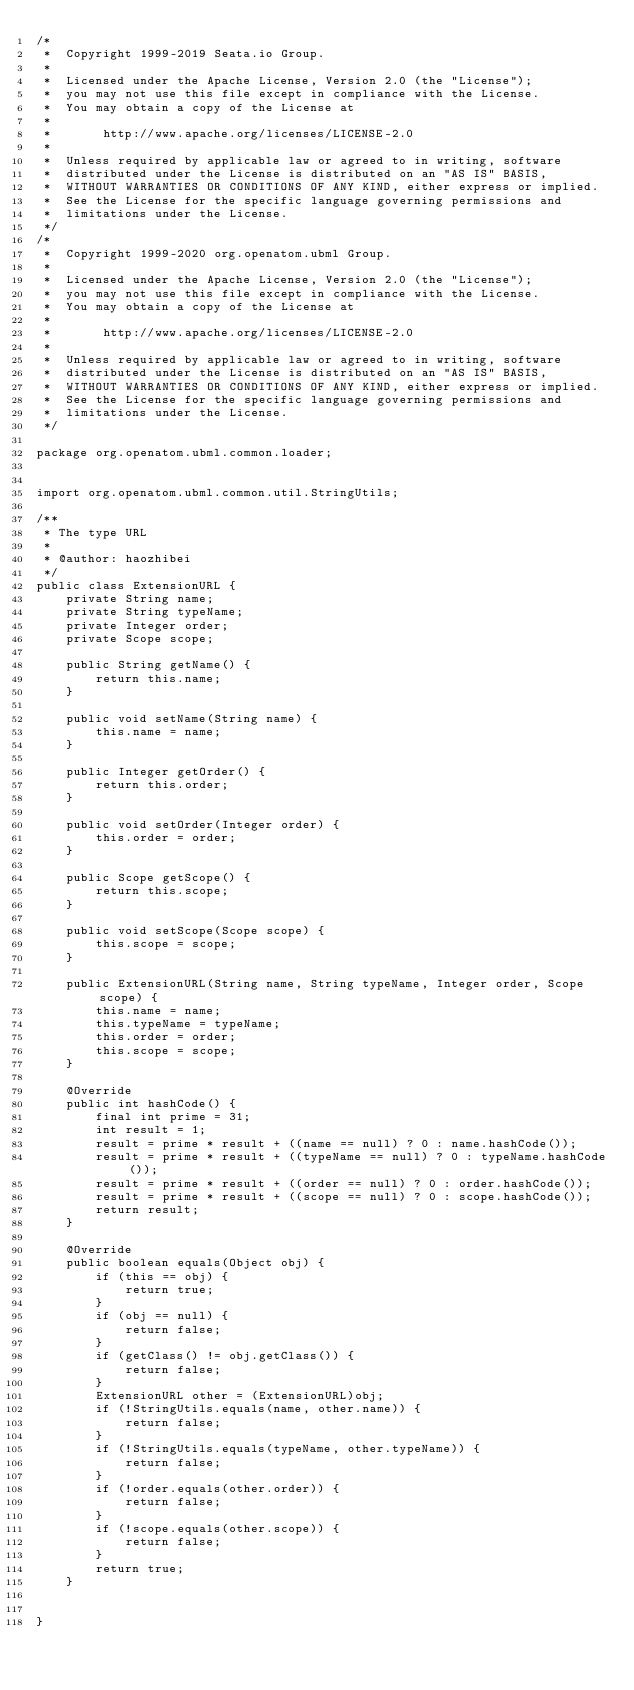<code> <loc_0><loc_0><loc_500><loc_500><_Java_>/*
 *  Copyright 1999-2019 Seata.io Group.
 *
 *  Licensed under the Apache License, Version 2.0 (the "License");
 *  you may not use this file except in compliance with the License.
 *  You may obtain a copy of the License at
 *
 *       http://www.apache.org/licenses/LICENSE-2.0
 *
 *  Unless required by applicable law or agreed to in writing, software
 *  distributed under the License is distributed on an "AS IS" BASIS,
 *  WITHOUT WARRANTIES OR CONDITIONS OF ANY KIND, either express or implied.
 *  See the License for the specific language governing permissions and
 *  limitations under the License.
 */
/*
 *  Copyright 1999-2020 org.openatom.ubml Group.
 *
 *  Licensed under the Apache License, Version 2.0 (the "License");
 *  you may not use this file except in compliance with the License.
 *  You may obtain a copy of the License at
 *
 *       http://www.apache.org/licenses/LICENSE-2.0
 *
 *  Unless required by applicable law or agreed to in writing, software
 *  distributed under the License is distributed on an "AS IS" BASIS,
 *  WITHOUT WARRANTIES OR CONDITIONS OF ANY KIND, either express or implied.
 *  See the License for the specific language governing permissions and
 *  limitations under the License.
 */

package org.openatom.ubml.common.loader;


import org.openatom.ubml.common.util.StringUtils;

/**
 * The type URL
 *
 * @author: haozhibei
 */
public class ExtensionURL {
    private String name;
    private String typeName;
    private Integer order;
    private Scope scope;

    public String getName() {
        return this.name;
    }

    public void setName(String name) {
        this.name = name;
    }

    public Integer getOrder() {
        return this.order;
    }

    public void setOrder(Integer order) {
        this.order = order;
    }

    public Scope getScope() {
        return this.scope;
    }

    public void setScope(Scope scope) {
        this.scope = scope;
    }

    public ExtensionURL(String name, String typeName, Integer order, Scope scope) {
        this.name = name;
        this.typeName = typeName;
        this.order = order;
        this.scope = scope;
    }

    @Override
    public int hashCode() {
        final int prime = 31;
        int result = 1;
        result = prime * result + ((name == null) ? 0 : name.hashCode());
        result = prime * result + ((typeName == null) ? 0 : typeName.hashCode());
        result = prime * result + ((order == null) ? 0 : order.hashCode());
        result = prime * result + ((scope == null) ? 0 : scope.hashCode());
        return result;
    }

    @Override
    public boolean equals(Object obj) {
        if (this == obj) {
            return true;
        }
        if (obj == null) {
            return false;
        }
        if (getClass() != obj.getClass()) {
            return false;
        }
        ExtensionURL other = (ExtensionURL)obj;
        if (!StringUtils.equals(name, other.name)) {
            return false;
        }
        if (!StringUtils.equals(typeName, other.typeName)) {
            return false;
        }
        if (!order.equals(other.order)) {
            return false;
        }
        if (!scope.equals(other.scope)) {
            return false;
        }
        return true;
    }


}
</code> 